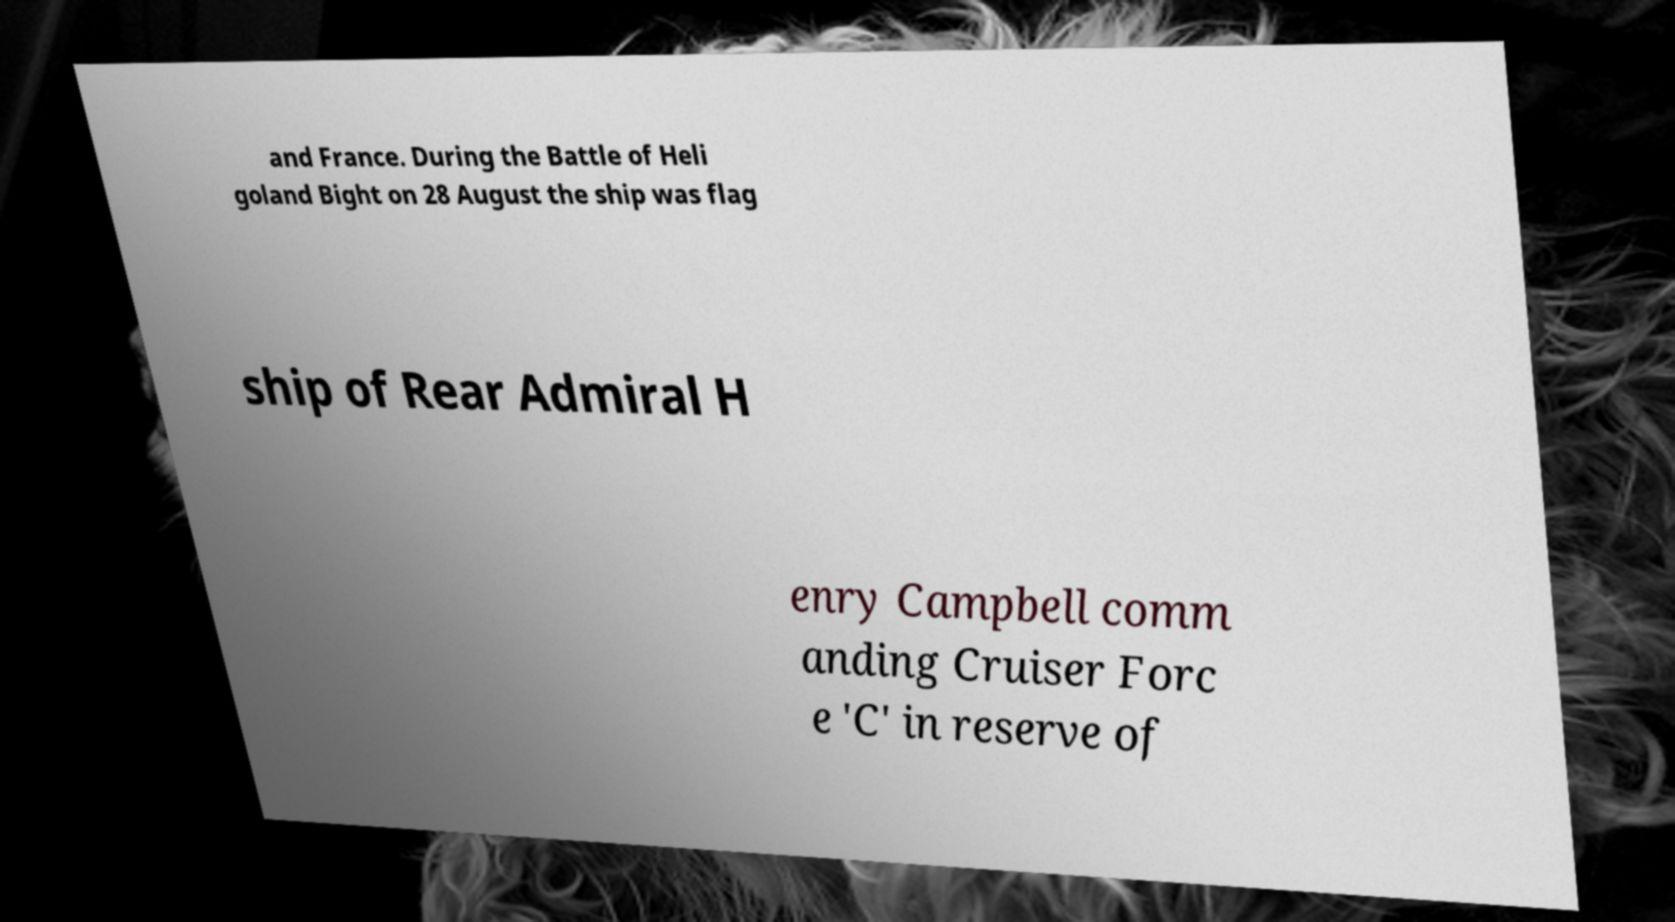Could you assist in decoding the text presented in this image and type it out clearly? and France. During the Battle of Heli goland Bight on 28 August the ship was flag ship of Rear Admiral H enry Campbell comm anding Cruiser Forc e 'C' in reserve of 